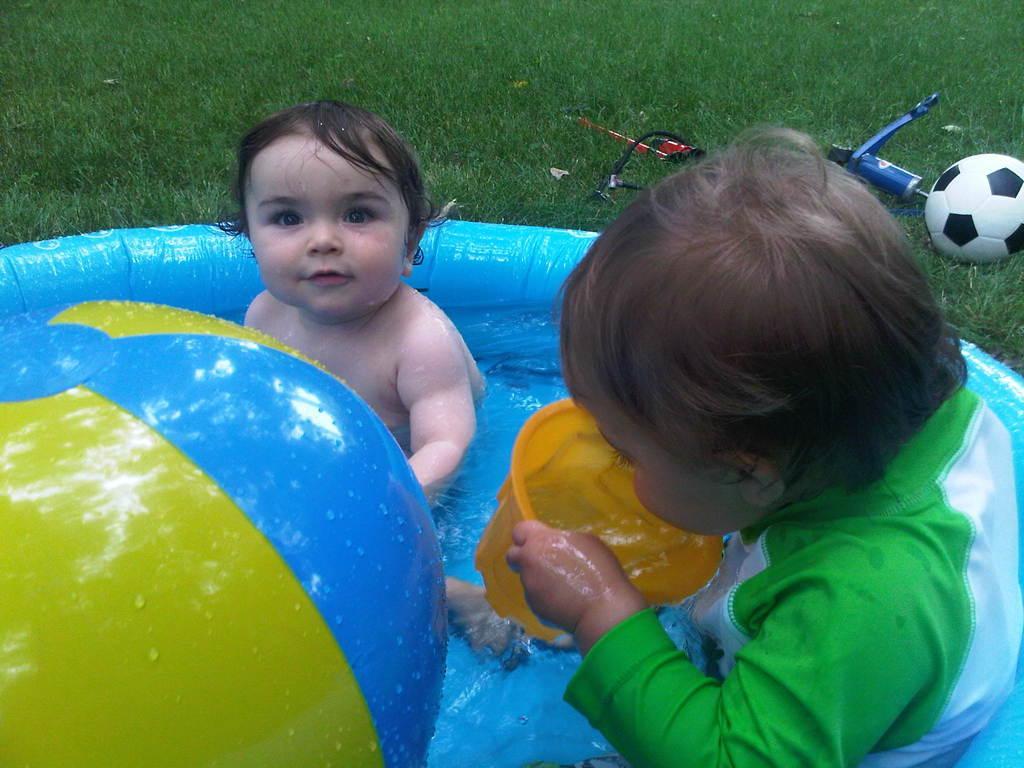Please provide a concise description of this image. In this image we can see kids playing in a water tub. There is a mug. There is grass. There are two objects like bottle. 